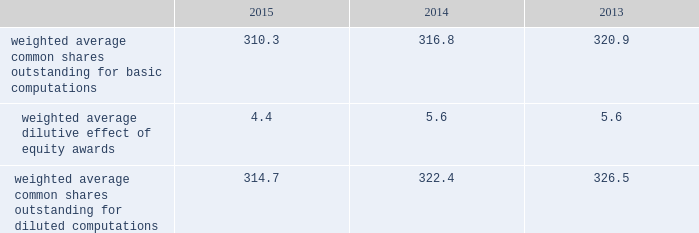2015 and 2014 was $ 1.5 billion and $ 1.3 billion .
The aggregate notional amount of our outstanding foreign currency hedges at december 31 , 2015 and 2014 was $ 4.1 billion and $ 804 million .
Derivative instruments did not have a material impact on net earnings and comprehensive income during 2015 , 2014 and 2013 .
Substantially all of our derivatives are designated for hedge accounting .
See note 16 for more information on the fair value measurements related to our derivative instruments .
Recent accounting pronouncements 2013 in may 2014 , the fasb issued a new standard that will change the way we recognize revenue and significantly expand the disclosure requirements for revenue arrangements .
On july 9 , 2015 , the fasb approved a one-year deferral of the effective date of the standard to 2018 for public companies , with an option that would permit companies to adopt the standard in 2017 .
Early adoption prior to 2017 is not permitted .
The new standard may be adopted either retrospectively or on a modified retrospective basis whereby the new standard would be applied to new contracts and existing contracts with remaining performance obligations as of the effective date , with a cumulative catch-up adjustment recorded to beginning retained earnings at the effective date for existing contracts with remaining performance obligations .
In addition , the fasb is contemplating making additional changes to certain elements of the new standard .
We are currently evaluating the methods of adoption allowed by the new standard and the effect the standard is expected to have on our consolidated financial statements and related disclosures .
As the new standard will supersede substantially all existing revenue guidance affecting us under gaap , it could impact revenue and cost recognition on thousands of contracts across all our business segments , in addition to our business processes and our information technology systems .
As a result , our evaluation of the effect of the new standard will extend over future periods .
In september 2015 , the fasb issued a new standard that simplifies the accounting for adjustments made to preliminary amounts recognized in a business combination by eliminating the requirement to retrospectively account for those adjustments .
Instead , adjustments will be recognized in the period in which the adjustments are determined , including the effect on earnings of any amounts that would have been recorded in previous periods if the accounting had been completed at the acquisition date .
We adopted the standard on january 1 , 2016 and will prospectively apply the standard to business combination adjustments identified after the date of adoption .
In november 2015 , the fasb issued a new standard that simplifies the presentation of deferred income taxes and requires that deferred tax assets and liabilities , as well as any related valuation allowance , be classified as noncurrent in our consolidated balance sheets .
The standard is effective january 1 , 2017 , with early adoption permitted .
The standard may be applied either prospectively from the date of adoption or retrospectively to all prior periods presented .
We are currently evaluating when we will adopt the standard and the method of adoption .
Note 2 2013 earnings per share the weighted average number of shares outstanding used to compute earnings per common share were as follows ( in millions ) : .
We compute basic and diluted earnings per common share by dividing net earnings by the respective weighted average number of common shares outstanding for the periods presented .
Our calculation of diluted earnings per common share also includes the dilutive effects for the assumed vesting of outstanding restricted stock units and exercise of outstanding stock options based on the treasury stock method .
The computation of diluted earnings per common share excluded 2.4 million stock options for the year ended december 31 , 2013 because their inclusion would have been anti-dilutive , primarily due to their exercise prices exceeding the average market prices of our common stock during the respective periods .
There were no anti-dilutive equity awards for the years ended december 31 , 2015 and 2014. .
What was the change in the percent of the weighted average common shares outstanding for diluted computations from 2014 to 2015? 
Computations: ((314.7 - 322.4) / 322.4)
Answer: -0.02388. 